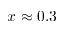<formula> <loc_0><loc_0><loc_500><loc_500>x \approx 0 . 3</formula> 